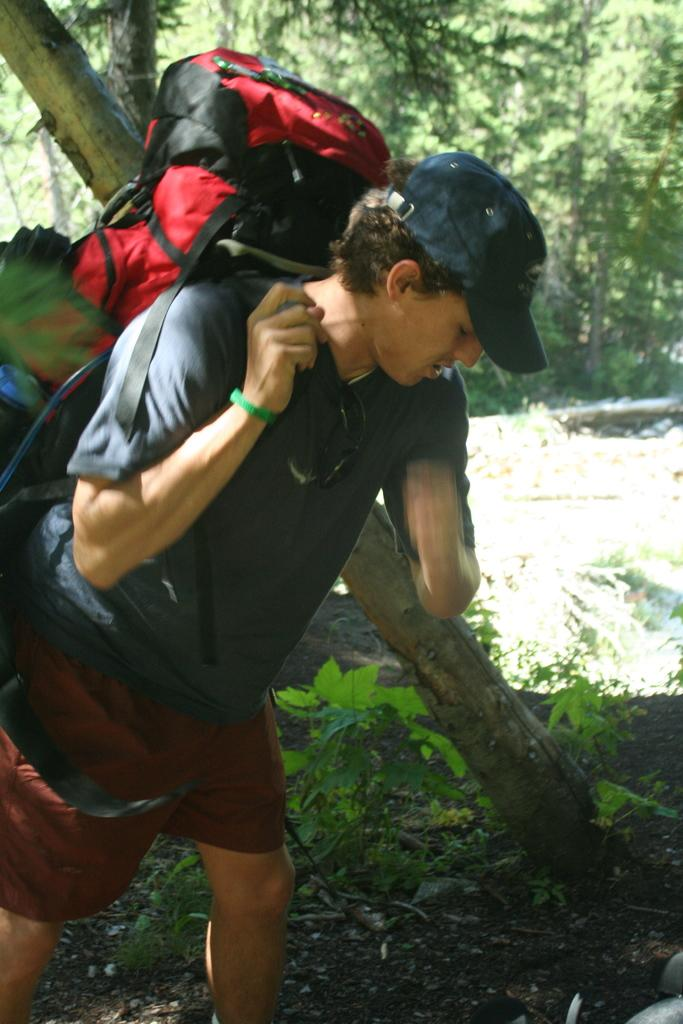What is the main subject of the image? There is a person in the image. What is the person wearing in the image? The person is wearing a bag in the image. What can be seen in the background of the image? There are trees in the background of the image. What type of surface is visible at the bottom of the image? Soil is visible at the bottom of the image. What type of vegetation is present at the bottom of the image? Plants are present at the bottom of the image. What type of cough does the person have in the image? There is no indication of a cough in the image; the person is simply wearing a bag. What type of relationship does the person have with the grandfather in the image? There is no mention of a grandfather in the image; the focus is on the person and their surroundings. 